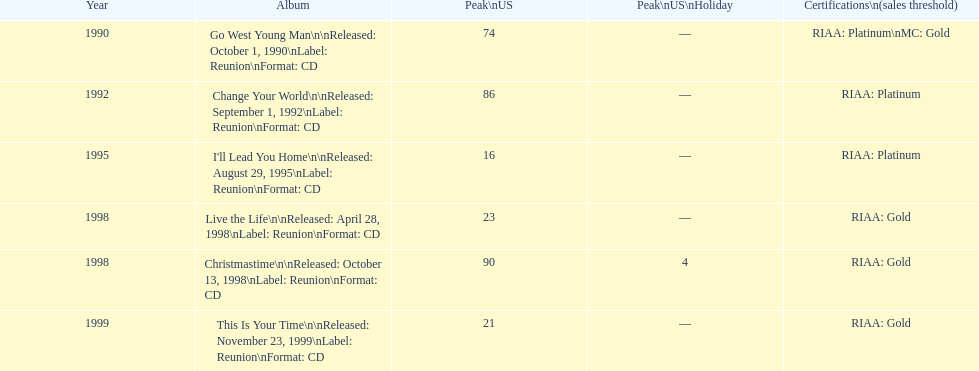Michael w. smith's initial album was called what? Go West Young Man. 